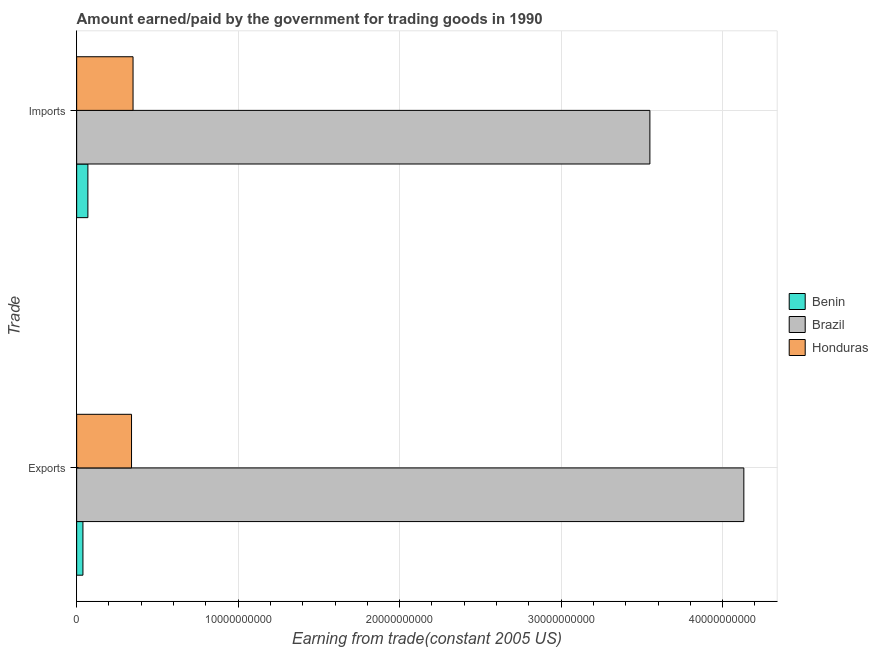Are the number of bars on each tick of the Y-axis equal?
Offer a terse response. Yes. How many bars are there on the 2nd tick from the top?
Offer a terse response. 3. How many bars are there on the 2nd tick from the bottom?
Provide a short and direct response. 3. What is the label of the 2nd group of bars from the top?
Keep it short and to the point. Exports. What is the amount paid for imports in Benin?
Your answer should be very brief. 6.96e+08. Across all countries, what is the maximum amount paid for imports?
Offer a terse response. 3.55e+1. Across all countries, what is the minimum amount earned from exports?
Keep it short and to the point. 3.89e+08. In which country was the amount paid for imports minimum?
Ensure brevity in your answer.  Benin. What is the total amount paid for imports in the graph?
Keep it short and to the point. 3.97e+1. What is the difference between the amount paid for imports in Benin and that in Brazil?
Give a very brief answer. -3.48e+1. What is the difference between the amount earned from exports in Benin and the amount paid for imports in Brazil?
Keep it short and to the point. -3.51e+1. What is the average amount earned from exports per country?
Your response must be concise. 1.50e+1. What is the difference between the amount paid for imports and amount earned from exports in Honduras?
Give a very brief answer. 9.42e+07. What is the ratio of the amount paid for imports in Honduras to that in Benin?
Provide a succinct answer. 5.02. What does the 1st bar from the top in Exports represents?
Give a very brief answer. Honduras. What does the 3rd bar from the bottom in Exports represents?
Provide a short and direct response. Honduras. How many bars are there?
Offer a terse response. 6. Are all the bars in the graph horizontal?
Offer a very short reply. Yes. How many countries are there in the graph?
Make the answer very short. 3. Does the graph contain grids?
Your answer should be very brief. Yes. Where does the legend appear in the graph?
Your answer should be very brief. Center right. How many legend labels are there?
Your response must be concise. 3. What is the title of the graph?
Your answer should be very brief. Amount earned/paid by the government for trading goods in 1990. Does "Netherlands" appear as one of the legend labels in the graph?
Your response must be concise. No. What is the label or title of the X-axis?
Ensure brevity in your answer.  Earning from trade(constant 2005 US). What is the label or title of the Y-axis?
Provide a succinct answer. Trade. What is the Earning from trade(constant 2005 US) in Benin in Exports?
Make the answer very short. 3.89e+08. What is the Earning from trade(constant 2005 US) in Brazil in Exports?
Offer a terse response. 4.13e+1. What is the Earning from trade(constant 2005 US) in Honduras in Exports?
Offer a terse response. 3.40e+09. What is the Earning from trade(constant 2005 US) in Benin in Imports?
Offer a terse response. 6.96e+08. What is the Earning from trade(constant 2005 US) of Brazil in Imports?
Offer a very short reply. 3.55e+1. What is the Earning from trade(constant 2005 US) in Honduras in Imports?
Provide a short and direct response. 3.49e+09. Across all Trade, what is the maximum Earning from trade(constant 2005 US) in Benin?
Give a very brief answer. 6.96e+08. Across all Trade, what is the maximum Earning from trade(constant 2005 US) in Brazil?
Keep it short and to the point. 4.13e+1. Across all Trade, what is the maximum Earning from trade(constant 2005 US) of Honduras?
Offer a very short reply. 3.49e+09. Across all Trade, what is the minimum Earning from trade(constant 2005 US) of Benin?
Keep it short and to the point. 3.89e+08. Across all Trade, what is the minimum Earning from trade(constant 2005 US) of Brazil?
Your answer should be compact. 3.55e+1. Across all Trade, what is the minimum Earning from trade(constant 2005 US) of Honduras?
Offer a terse response. 3.40e+09. What is the total Earning from trade(constant 2005 US) of Benin in the graph?
Provide a short and direct response. 1.08e+09. What is the total Earning from trade(constant 2005 US) in Brazil in the graph?
Provide a short and direct response. 7.68e+1. What is the total Earning from trade(constant 2005 US) in Honduras in the graph?
Ensure brevity in your answer.  6.89e+09. What is the difference between the Earning from trade(constant 2005 US) of Benin in Exports and that in Imports?
Offer a terse response. -3.07e+08. What is the difference between the Earning from trade(constant 2005 US) in Brazil in Exports and that in Imports?
Your answer should be compact. 5.82e+09. What is the difference between the Earning from trade(constant 2005 US) in Honduras in Exports and that in Imports?
Provide a short and direct response. -9.42e+07. What is the difference between the Earning from trade(constant 2005 US) in Benin in Exports and the Earning from trade(constant 2005 US) in Brazil in Imports?
Keep it short and to the point. -3.51e+1. What is the difference between the Earning from trade(constant 2005 US) of Benin in Exports and the Earning from trade(constant 2005 US) of Honduras in Imports?
Make the answer very short. -3.10e+09. What is the difference between the Earning from trade(constant 2005 US) of Brazil in Exports and the Earning from trade(constant 2005 US) of Honduras in Imports?
Provide a short and direct response. 3.78e+1. What is the average Earning from trade(constant 2005 US) of Benin per Trade?
Your answer should be compact. 5.42e+08. What is the average Earning from trade(constant 2005 US) in Brazil per Trade?
Keep it short and to the point. 3.84e+1. What is the average Earning from trade(constant 2005 US) in Honduras per Trade?
Give a very brief answer. 3.44e+09. What is the difference between the Earning from trade(constant 2005 US) in Benin and Earning from trade(constant 2005 US) in Brazil in Exports?
Give a very brief answer. -4.09e+1. What is the difference between the Earning from trade(constant 2005 US) of Benin and Earning from trade(constant 2005 US) of Honduras in Exports?
Make the answer very short. -3.01e+09. What is the difference between the Earning from trade(constant 2005 US) of Brazil and Earning from trade(constant 2005 US) of Honduras in Exports?
Your answer should be compact. 3.79e+1. What is the difference between the Earning from trade(constant 2005 US) in Benin and Earning from trade(constant 2005 US) in Brazil in Imports?
Provide a succinct answer. -3.48e+1. What is the difference between the Earning from trade(constant 2005 US) in Benin and Earning from trade(constant 2005 US) in Honduras in Imports?
Keep it short and to the point. -2.80e+09. What is the difference between the Earning from trade(constant 2005 US) of Brazil and Earning from trade(constant 2005 US) of Honduras in Imports?
Ensure brevity in your answer.  3.20e+1. What is the ratio of the Earning from trade(constant 2005 US) in Benin in Exports to that in Imports?
Make the answer very short. 0.56. What is the ratio of the Earning from trade(constant 2005 US) of Brazil in Exports to that in Imports?
Ensure brevity in your answer.  1.16. What is the ratio of the Earning from trade(constant 2005 US) of Honduras in Exports to that in Imports?
Provide a succinct answer. 0.97. What is the difference between the highest and the second highest Earning from trade(constant 2005 US) in Benin?
Give a very brief answer. 3.07e+08. What is the difference between the highest and the second highest Earning from trade(constant 2005 US) of Brazil?
Ensure brevity in your answer.  5.82e+09. What is the difference between the highest and the second highest Earning from trade(constant 2005 US) in Honduras?
Make the answer very short. 9.42e+07. What is the difference between the highest and the lowest Earning from trade(constant 2005 US) in Benin?
Your answer should be compact. 3.07e+08. What is the difference between the highest and the lowest Earning from trade(constant 2005 US) in Brazil?
Provide a succinct answer. 5.82e+09. What is the difference between the highest and the lowest Earning from trade(constant 2005 US) of Honduras?
Make the answer very short. 9.42e+07. 